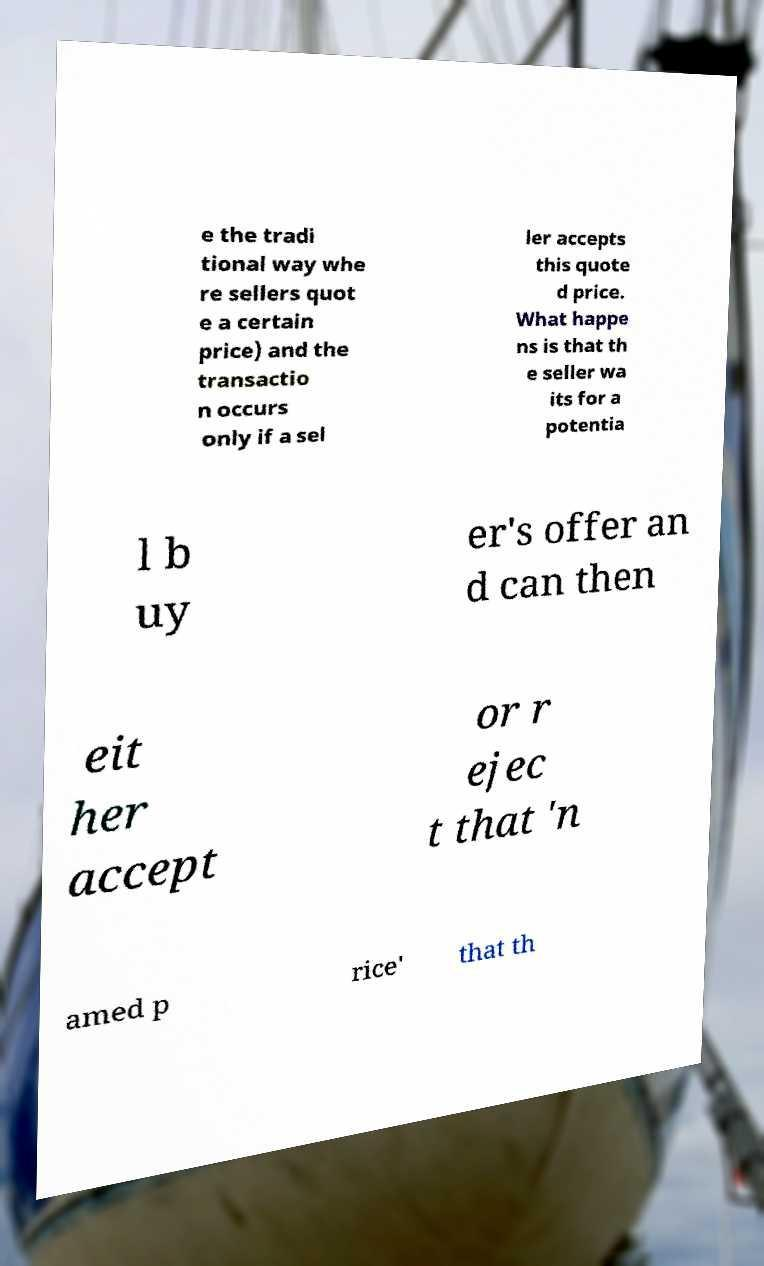Can you read and provide the text displayed in the image?This photo seems to have some interesting text. Can you extract and type it out for me? e the tradi tional way whe re sellers quot e a certain price) and the transactio n occurs only if a sel ler accepts this quote d price. What happe ns is that th e seller wa its for a potentia l b uy er's offer an d can then eit her accept or r ejec t that 'n amed p rice' that th 